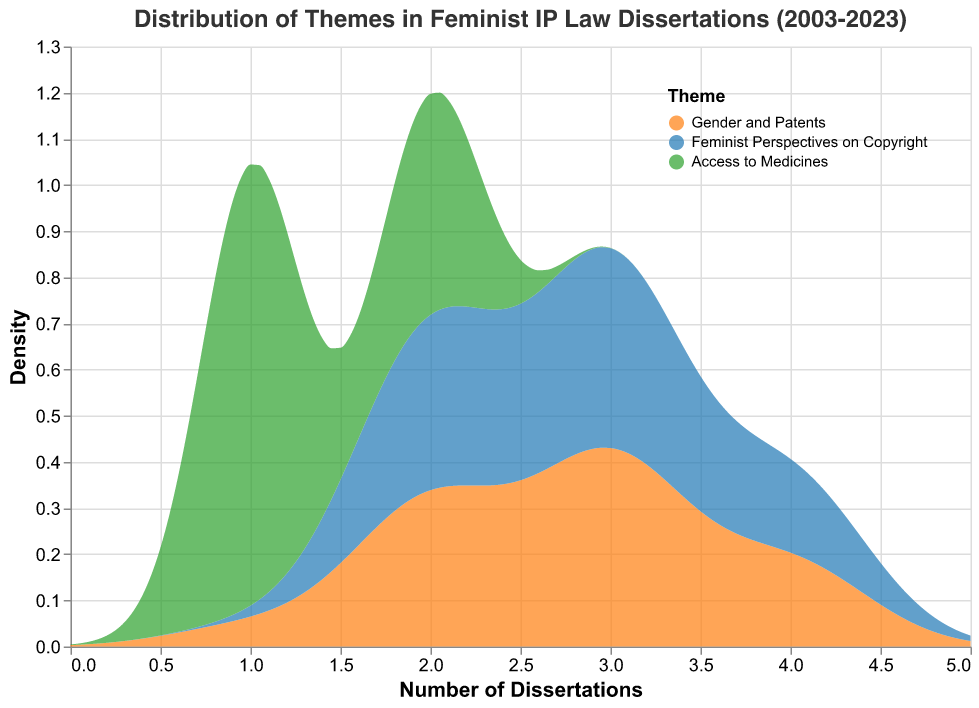What themes are analyzed in the density plot? The legend at the top-right of the plot shows the themes color-coded: Gender and Patents (orange), Feminist Perspectives on Copyright (blue), and Access to Medicines (green).
Answer: Gender and Patents, Feminist Perspectives on Copyright, Access to Medicines What does the x-axis represent in the density plot? The x-axis represents the "Number of Dissertations," indicating the count of dissertations for each theme across different years.
Answer: Number of Dissertations What does the y-axis indicate in this density plot? The y-axis represents the "Density," which indicates the density of dissertation counts for each theme over the defined interval.
Answer: Density Which theme has the highest density peak in the distribution? By observing the plot, the theme "Feminist Perspectives on Copyright" (blue) reaches the highest peak in density among the three themes.
Answer: Feminist Perspectives on Copyright Between "Gender and Patents" and "Access to Medicines," which theme shows a wider spread in density? "Gender and Patents" (orange) shows a wider spread in density as compared to "Access to Medicines" (green), indicating variability across the number of dissertations.
Answer: Gender and Patents How does the density distribution of "Feminist Perspectives on Copyright" compare to "Access to Medicines"? The density of "Feminist Perspectives on Copyright" (blue) is generally higher than "Access to Medicines" (green), showing more frequent dissertation counts within its range.
Answer: Feminist Perspectives on Copyright is higher What can you infer about the density distribution of Gender and Patents between 2 and 4 dissertations? The density distribution shows that "Gender and Patents" (orange) has consistent peaks at ranges between 2 and 4 dissertations, indicating these values were commonly observed.
Answer: Consistent peaks Which theme appears to have the smallest peak in density distribution? "Access to Medicines" (green) has the smallest peak, suggesting it had fewer dissertations compared to the other themes.
Answer: Access to Medicines Among the themes, which one appears to have a more consistent density across different dissertation counts? "Gender and Patents" (orange) shows a more consistent density across different dissertation counts, indicating a more uniform distribution.
Answer: Gender and Patents 